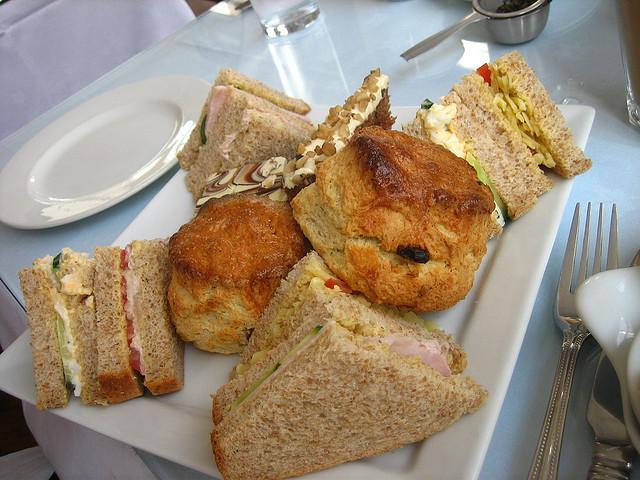Is this a doll's tea party?
Quick response, please. No. Is this meal suitable for a person on a diet?
Quick response, please. No. Is this a club sandwich?
Answer briefly. Yes. How many times was the sandwich cut?
Write a very short answer. 2. 